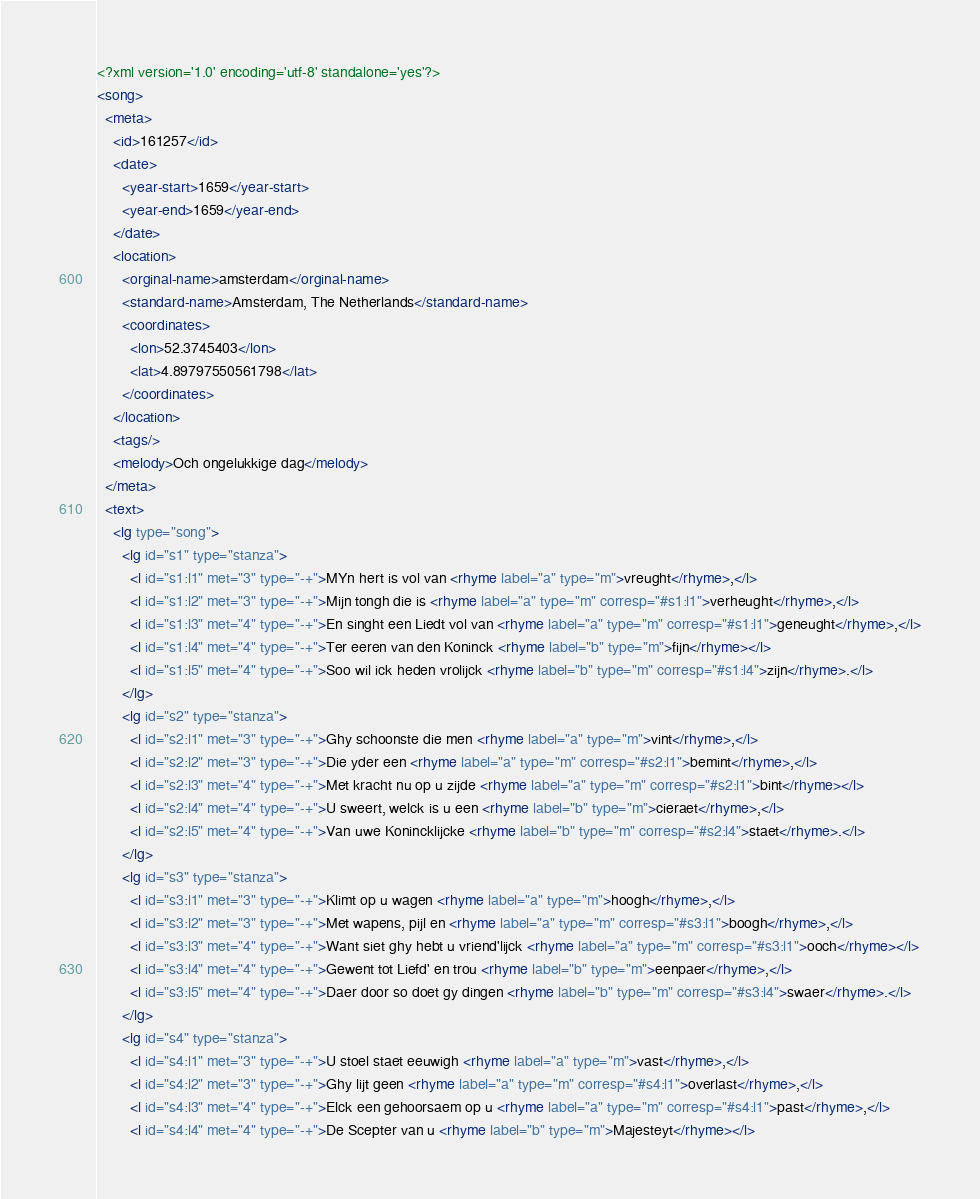<code> <loc_0><loc_0><loc_500><loc_500><_XML_><?xml version='1.0' encoding='utf-8' standalone='yes'?>
<song>
  <meta>
    <id>161257</id>
    <date>
      <year-start>1659</year-start>
      <year-end>1659</year-end>
    </date>
    <location>
      <orginal-name>amsterdam</orginal-name>
      <standard-name>Amsterdam, The Netherlands</standard-name>
      <coordinates>
        <lon>52.3745403</lon>
        <lat>4.89797550561798</lat>
      </coordinates>
    </location>
    <tags/>
    <melody>Och ongelukkige dag</melody>
  </meta>
  <text>
    <lg type="song">
      <lg id="s1" type="stanza">
        <l id="s1:l1" met="3" type="-+">MYn hert is vol van <rhyme label="a" type="m">vreught</rhyme>,</l>
        <l id="s1:l2" met="3" type="-+">Mijn tongh die is <rhyme label="a" type="m" corresp="#s1:l1">verheught</rhyme>,</l>
        <l id="s1:l3" met="4" type="-+">En singht een Liedt vol van <rhyme label="a" type="m" corresp="#s1:l1">geneught</rhyme>,</l>
        <l id="s1:l4" met="4" type="-+">Ter eeren van den Koninck <rhyme label="b" type="m">fijn</rhyme></l>
        <l id="s1:l5" met="4" type="-+">Soo wil ick heden vrolijck <rhyme label="b" type="m" corresp="#s1:l4">zijn</rhyme>.</l>
      </lg>
      <lg id="s2" type="stanza">
        <l id="s2:l1" met="3" type="-+">Ghy schoonste die men <rhyme label="a" type="m">vint</rhyme>,</l>
        <l id="s2:l2" met="3" type="-+">Die yder een <rhyme label="a" type="m" corresp="#s2:l1">bemint</rhyme>,</l>
        <l id="s2:l3" met="4" type="-+">Met kracht nu op u zijde <rhyme label="a" type="m" corresp="#s2:l1">bint</rhyme></l>
        <l id="s2:l4" met="4" type="-+">U sweert, welck is u een <rhyme label="b" type="m">cieraet</rhyme>,</l>
        <l id="s2:l5" met="4" type="-+">Van uwe Konincklijcke <rhyme label="b" type="m" corresp="#s2:l4">staet</rhyme>.</l>
      </lg>
      <lg id="s3" type="stanza">
        <l id="s3:l1" met="3" type="-+">Klimt op u wagen <rhyme label="a" type="m">hoogh</rhyme>,</l>
        <l id="s3:l2" met="3" type="-+">Met wapens, pijl en <rhyme label="a" type="m" corresp="#s3:l1">boogh</rhyme>,</l>
        <l id="s3:l3" met="4" type="-+">Want siet ghy hebt u vriend'lijck <rhyme label="a" type="m" corresp="#s3:l1">ooch</rhyme></l>
        <l id="s3:l4" met="4" type="-+">Gewent tot Liefd' en trou <rhyme label="b" type="m">eenpaer</rhyme>,</l>
        <l id="s3:l5" met="4" type="-+">Daer door so doet gy dingen <rhyme label="b" type="m" corresp="#s3:l4">swaer</rhyme>.</l>
      </lg>
      <lg id="s4" type="stanza">
        <l id="s4:l1" met="3" type="-+">U stoel staet eeuwigh <rhyme label="a" type="m">vast</rhyme>,</l>
        <l id="s4:l2" met="3" type="-+">Ghy lijt geen <rhyme label="a" type="m" corresp="#s4:l1">overlast</rhyme>,</l>
        <l id="s4:l3" met="4" type="-+">Elck een gehoorsaem op u <rhyme label="a" type="m" corresp="#s4:l1">past</rhyme>,</l>
        <l id="s4:l4" met="4" type="-+">De Scepter van u <rhyme label="b" type="m">Majesteyt</rhyme></l></code> 